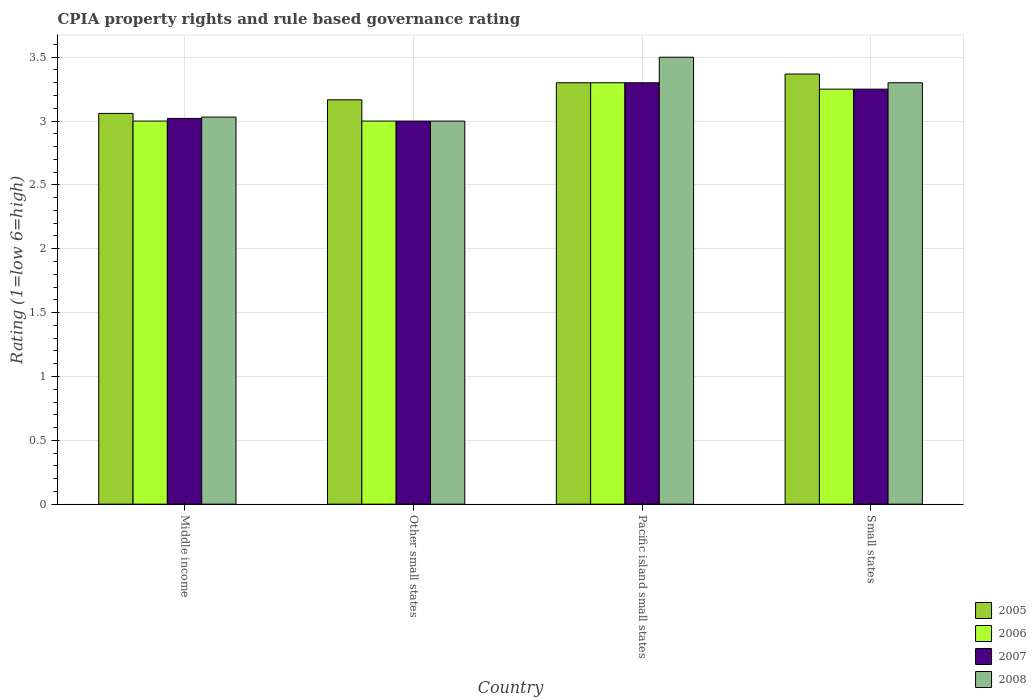How many groups of bars are there?
Make the answer very short. 4. Are the number of bars on each tick of the X-axis equal?
Your answer should be very brief. Yes. How many bars are there on the 4th tick from the right?
Your answer should be compact. 4. What is the label of the 1st group of bars from the left?
Your response must be concise. Middle income. In how many cases, is the number of bars for a given country not equal to the number of legend labels?
Your answer should be very brief. 0. Across all countries, what is the maximum CPIA rating in 2005?
Make the answer very short. 3.37. In which country was the CPIA rating in 2005 maximum?
Ensure brevity in your answer.  Small states. In which country was the CPIA rating in 2007 minimum?
Make the answer very short. Other small states. What is the total CPIA rating in 2008 in the graph?
Provide a short and direct response. 12.83. What is the difference between the CPIA rating in 2007 in Middle income and that in Small states?
Provide a short and direct response. -0.23. What is the difference between the CPIA rating in 2008 in Small states and the CPIA rating in 2006 in Pacific island small states?
Ensure brevity in your answer.  0. What is the average CPIA rating in 2007 per country?
Make the answer very short. 3.14. What is the difference between the CPIA rating of/in 2005 and CPIA rating of/in 2007 in Small states?
Offer a terse response. 0.12. In how many countries, is the CPIA rating in 2007 greater than 1.6?
Offer a terse response. 4. What is the ratio of the CPIA rating in 2006 in Other small states to that in Pacific island small states?
Provide a short and direct response. 0.91. What is the difference between the highest and the second highest CPIA rating in 2008?
Give a very brief answer. 0.27. What is the difference between the highest and the lowest CPIA rating in 2006?
Provide a short and direct response. 0.3. Is the sum of the CPIA rating in 2007 in Middle income and Other small states greater than the maximum CPIA rating in 2005 across all countries?
Ensure brevity in your answer.  Yes. Is it the case that in every country, the sum of the CPIA rating in 2008 and CPIA rating in 2007 is greater than the sum of CPIA rating in 2005 and CPIA rating in 2006?
Give a very brief answer. No. What does the 2nd bar from the left in Pacific island small states represents?
Your response must be concise. 2006. Where does the legend appear in the graph?
Your answer should be very brief. Bottom right. How many legend labels are there?
Keep it short and to the point. 4. How are the legend labels stacked?
Offer a very short reply. Vertical. What is the title of the graph?
Provide a short and direct response. CPIA property rights and rule based governance rating. What is the label or title of the X-axis?
Keep it short and to the point. Country. What is the Rating (1=low 6=high) of 2005 in Middle income?
Provide a short and direct response. 3.06. What is the Rating (1=low 6=high) of 2007 in Middle income?
Provide a short and direct response. 3.02. What is the Rating (1=low 6=high) of 2008 in Middle income?
Provide a succinct answer. 3.03. What is the Rating (1=low 6=high) of 2005 in Other small states?
Provide a succinct answer. 3.17. What is the Rating (1=low 6=high) of 2006 in Other small states?
Provide a succinct answer. 3. What is the Rating (1=low 6=high) of 2007 in Other small states?
Offer a very short reply. 3. What is the Rating (1=low 6=high) in 2005 in Pacific island small states?
Your response must be concise. 3.3. What is the Rating (1=low 6=high) of 2006 in Pacific island small states?
Offer a very short reply. 3.3. What is the Rating (1=low 6=high) in 2007 in Pacific island small states?
Provide a short and direct response. 3.3. What is the Rating (1=low 6=high) of 2005 in Small states?
Keep it short and to the point. 3.37. What is the Rating (1=low 6=high) in 2008 in Small states?
Make the answer very short. 3.3. Across all countries, what is the maximum Rating (1=low 6=high) of 2005?
Ensure brevity in your answer.  3.37. Across all countries, what is the maximum Rating (1=low 6=high) in 2006?
Offer a very short reply. 3.3. Across all countries, what is the maximum Rating (1=low 6=high) of 2007?
Offer a very short reply. 3.3. Across all countries, what is the maximum Rating (1=low 6=high) in 2008?
Offer a terse response. 3.5. Across all countries, what is the minimum Rating (1=low 6=high) in 2005?
Keep it short and to the point. 3.06. Across all countries, what is the minimum Rating (1=low 6=high) of 2006?
Provide a short and direct response. 3. Across all countries, what is the minimum Rating (1=low 6=high) in 2007?
Make the answer very short. 3. Across all countries, what is the minimum Rating (1=low 6=high) in 2008?
Your answer should be very brief. 3. What is the total Rating (1=low 6=high) in 2005 in the graph?
Keep it short and to the point. 12.9. What is the total Rating (1=low 6=high) of 2006 in the graph?
Your response must be concise. 12.55. What is the total Rating (1=low 6=high) of 2007 in the graph?
Make the answer very short. 12.57. What is the total Rating (1=low 6=high) of 2008 in the graph?
Provide a succinct answer. 12.83. What is the difference between the Rating (1=low 6=high) in 2005 in Middle income and that in Other small states?
Your response must be concise. -0.11. What is the difference between the Rating (1=low 6=high) of 2007 in Middle income and that in Other small states?
Your answer should be very brief. 0.02. What is the difference between the Rating (1=low 6=high) of 2008 in Middle income and that in Other small states?
Provide a short and direct response. 0.03. What is the difference between the Rating (1=low 6=high) of 2005 in Middle income and that in Pacific island small states?
Your response must be concise. -0.24. What is the difference between the Rating (1=low 6=high) of 2006 in Middle income and that in Pacific island small states?
Your answer should be compact. -0.3. What is the difference between the Rating (1=low 6=high) in 2007 in Middle income and that in Pacific island small states?
Offer a terse response. -0.28. What is the difference between the Rating (1=low 6=high) of 2008 in Middle income and that in Pacific island small states?
Your answer should be very brief. -0.47. What is the difference between the Rating (1=low 6=high) in 2005 in Middle income and that in Small states?
Provide a short and direct response. -0.31. What is the difference between the Rating (1=low 6=high) in 2007 in Middle income and that in Small states?
Offer a terse response. -0.23. What is the difference between the Rating (1=low 6=high) in 2008 in Middle income and that in Small states?
Your response must be concise. -0.27. What is the difference between the Rating (1=low 6=high) in 2005 in Other small states and that in Pacific island small states?
Your answer should be compact. -0.13. What is the difference between the Rating (1=low 6=high) of 2007 in Other small states and that in Pacific island small states?
Offer a terse response. -0.3. What is the difference between the Rating (1=low 6=high) of 2005 in Other small states and that in Small states?
Your response must be concise. -0.2. What is the difference between the Rating (1=low 6=high) in 2006 in Other small states and that in Small states?
Your answer should be compact. -0.25. What is the difference between the Rating (1=low 6=high) in 2007 in Other small states and that in Small states?
Ensure brevity in your answer.  -0.25. What is the difference between the Rating (1=low 6=high) of 2008 in Other small states and that in Small states?
Provide a short and direct response. -0.3. What is the difference between the Rating (1=low 6=high) in 2005 in Pacific island small states and that in Small states?
Make the answer very short. -0.07. What is the difference between the Rating (1=low 6=high) in 2007 in Pacific island small states and that in Small states?
Keep it short and to the point. 0.05. What is the difference between the Rating (1=low 6=high) of 2007 in Middle income and the Rating (1=low 6=high) of 2008 in Other small states?
Offer a terse response. 0.02. What is the difference between the Rating (1=low 6=high) of 2005 in Middle income and the Rating (1=low 6=high) of 2006 in Pacific island small states?
Your answer should be compact. -0.24. What is the difference between the Rating (1=low 6=high) in 2005 in Middle income and the Rating (1=low 6=high) in 2007 in Pacific island small states?
Your answer should be compact. -0.24. What is the difference between the Rating (1=low 6=high) of 2005 in Middle income and the Rating (1=low 6=high) of 2008 in Pacific island small states?
Provide a succinct answer. -0.44. What is the difference between the Rating (1=low 6=high) of 2006 in Middle income and the Rating (1=low 6=high) of 2007 in Pacific island small states?
Provide a succinct answer. -0.3. What is the difference between the Rating (1=low 6=high) of 2006 in Middle income and the Rating (1=low 6=high) of 2008 in Pacific island small states?
Ensure brevity in your answer.  -0.5. What is the difference between the Rating (1=low 6=high) in 2007 in Middle income and the Rating (1=low 6=high) in 2008 in Pacific island small states?
Provide a succinct answer. -0.48. What is the difference between the Rating (1=low 6=high) in 2005 in Middle income and the Rating (1=low 6=high) in 2006 in Small states?
Keep it short and to the point. -0.19. What is the difference between the Rating (1=low 6=high) of 2005 in Middle income and the Rating (1=low 6=high) of 2007 in Small states?
Offer a terse response. -0.19. What is the difference between the Rating (1=low 6=high) in 2005 in Middle income and the Rating (1=low 6=high) in 2008 in Small states?
Your response must be concise. -0.24. What is the difference between the Rating (1=low 6=high) of 2007 in Middle income and the Rating (1=low 6=high) of 2008 in Small states?
Your answer should be compact. -0.28. What is the difference between the Rating (1=low 6=high) in 2005 in Other small states and the Rating (1=low 6=high) in 2006 in Pacific island small states?
Your answer should be very brief. -0.13. What is the difference between the Rating (1=low 6=high) of 2005 in Other small states and the Rating (1=low 6=high) of 2007 in Pacific island small states?
Ensure brevity in your answer.  -0.13. What is the difference between the Rating (1=low 6=high) of 2006 in Other small states and the Rating (1=low 6=high) of 2007 in Pacific island small states?
Offer a terse response. -0.3. What is the difference between the Rating (1=low 6=high) in 2007 in Other small states and the Rating (1=low 6=high) in 2008 in Pacific island small states?
Your answer should be compact. -0.5. What is the difference between the Rating (1=low 6=high) in 2005 in Other small states and the Rating (1=low 6=high) in 2006 in Small states?
Provide a short and direct response. -0.08. What is the difference between the Rating (1=low 6=high) in 2005 in Other small states and the Rating (1=low 6=high) in 2007 in Small states?
Offer a very short reply. -0.08. What is the difference between the Rating (1=low 6=high) in 2005 in Other small states and the Rating (1=low 6=high) in 2008 in Small states?
Your answer should be very brief. -0.13. What is the difference between the Rating (1=low 6=high) of 2007 in Other small states and the Rating (1=low 6=high) of 2008 in Small states?
Provide a short and direct response. -0.3. What is the difference between the Rating (1=low 6=high) of 2005 in Pacific island small states and the Rating (1=low 6=high) of 2008 in Small states?
Make the answer very short. 0. What is the difference between the Rating (1=low 6=high) of 2006 in Pacific island small states and the Rating (1=low 6=high) of 2008 in Small states?
Offer a very short reply. 0. What is the average Rating (1=low 6=high) of 2005 per country?
Your response must be concise. 3.22. What is the average Rating (1=low 6=high) in 2006 per country?
Offer a very short reply. 3.14. What is the average Rating (1=low 6=high) of 2007 per country?
Offer a very short reply. 3.14. What is the average Rating (1=low 6=high) of 2008 per country?
Offer a terse response. 3.21. What is the difference between the Rating (1=low 6=high) in 2005 and Rating (1=low 6=high) in 2007 in Middle income?
Keep it short and to the point. 0.04. What is the difference between the Rating (1=low 6=high) in 2005 and Rating (1=low 6=high) in 2008 in Middle income?
Your answer should be very brief. 0.03. What is the difference between the Rating (1=low 6=high) in 2006 and Rating (1=low 6=high) in 2007 in Middle income?
Make the answer very short. -0.02. What is the difference between the Rating (1=low 6=high) in 2006 and Rating (1=low 6=high) in 2008 in Middle income?
Offer a terse response. -0.03. What is the difference between the Rating (1=low 6=high) in 2007 and Rating (1=low 6=high) in 2008 in Middle income?
Ensure brevity in your answer.  -0.01. What is the difference between the Rating (1=low 6=high) in 2005 and Rating (1=low 6=high) in 2006 in Other small states?
Keep it short and to the point. 0.17. What is the difference between the Rating (1=low 6=high) of 2005 and Rating (1=low 6=high) of 2007 in Other small states?
Provide a succinct answer. 0.17. What is the difference between the Rating (1=low 6=high) of 2005 and Rating (1=low 6=high) of 2008 in Other small states?
Offer a very short reply. 0.17. What is the difference between the Rating (1=low 6=high) in 2006 and Rating (1=low 6=high) in 2007 in Other small states?
Provide a short and direct response. 0. What is the difference between the Rating (1=low 6=high) in 2006 and Rating (1=low 6=high) in 2008 in Other small states?
Provide a succinct answer. 0. What is the difference between the Rating (1=low 6=high) in 2007 and Rating (1=low 6=high) in 2008 in Pacific island small states?
Give a very brief answer. -0.2. What is the difference between the Rating (1=low 6=high) in 2005 and Rating (1=low 6=high) in 2006 in Small states?
Provide a short and direct response. 0.12. What is the difference between the Rating (1=low 6=high) of 2005 and Rating (1=low 6=high) of 2007 in Small states?
Your answer should be very brief. 0.12. What is the difference between the Rating (1=low 6=high) of 2005 and Rating (1=low 6=high) of 2008 in Small states?
Offer a very short reply. 0.07. What is the difference between the Rating (1=low 6=high) of 2006 and Rating (1=low 6=high) of 2008 in Small states?
Keep it short and to the point. -0.05. What is the difference between the Rating (1=low 6=high) of 2007 and Rating (1=low 6=high) of 2008 in Small states?
Provide a succinct answer. -0.05. What is the ratio of the Rating (1=low 6=high) in 2005 in Middle income to that in Other small states?
Offer a terse response. 0.97. What is the ratio of the Rating (1=low 6=high) of 2006 in Middle income to that in Other small states?
Offer a very short reply. 1. What is the ratio of the Rating (1=low 6=high) in 2007 in Middle income to that in Other small states?
Your answer should be very brief. 1.01. What is the ratio of the Rating (1=low 6=high) of 2008 in Middle income to that in Other small states?
Give a very brief answer. 1.01. What is the ratio of the Rating (1=low 6=high) of 2005 in Middle income to that in Pacific island small states?
Your answer should be very brief. 0.93. What is the ratio of the Rating (1=low 6=high) of 2006 in Middle income to that in Pacific island small states?
Offer a very short reply. 0.91. What is the ratio of the Rating (1=low 6=high) in 2007 in Middle income to that in Pacific island small states?
Your response must be concise. 0.92. What is the ratio of the Rating (1=low 6=high) of 2008 in Middle income to that in Pacific island small states?
Your response must be concise. 0.87. What is the ratio of the Rating (1=low 6=high) in 2005 in Middle income to that in Small states?
Keep it short and to the point. 0.91. What is the ratio of the Rating (1=low 6=high) of 2006 in Middle income to that in Small states?
Your answer should be very brief. 0.92. What is the ratio of the Rating (1=low 6=high) in 2007 in Middle income to that in Small states?
Make the answer very short. 0.93. What is the ratio of the Rating (1=low 6=high) in 2008 in Middle income to that in Small states?
Your answer should be very brief. 0.92. What is the ratio of the Rating (1=low 6=high) of 2005 in Other small states to that in Pacific island small states?
Your response must be concise. 0.96. What is the ratio of the Rating (1=low 6=high) of 2006 in Other small states to that in Pacific island small states?
Your response must be concise. 0.91. What is the ratio of the Rating (1=low 6=high) of 2007 in Other small states to that in Pacific island small states?
Ensure brevity in your answer.  0.91. What is the ratio of the Rating (1=low 6=high) in 2008 in Other small states to that in Pacific island small states?
Your answer should be compact. 0.86. What is the ratio of the Rating (1=low 6=high) in 2005 in Other small states to that in Small states?
Your response must be concise. 0.94. What is the ratio of the Rating (1=low 6=high) in 2006 in Other small states to that in Small states?
Your answer should be very brief. 0.92. What is the ratio of the Rating (1=low 6=high) of 2007 in Other small states to that in Small states?
Your answer should be compact. 0.92. What is the ratio of the Rating (1=low 6=high) in 2008 in Other small states to that in Small states?
Provide a short and direct response. 0.91. What is the ratio of the Rating (1=low 6=high) of 2005 in Pacific island small states to that in Small states?
Provide a succinct answer. 0.98. What is the ratio of the Rating (1=low 6=high) in 2006 in Pacific island small states to that in Small states?
Your answer should be very brief. 1.02. What is the ratio of the Rating (1=low 6=high) of 2007 in Pacific island small states to that in Small states?
Offer a very short reply. 1.02. What is the ratio of the Rating (1=low 6=high) in 2008 in Pacific island small states to that in Small states?
Give a very brief answer. 1.06. What is the difference between the highest and the second highest Rating (1=low 6=high) in 2005?
Keep it short and to the point. 0.07. What is the difference between the highest and the second highest Rating (1=low 6=high) of 2006?
Your response must be concise. 0.05. What is the difference between the highest and the second highest Rating (1=low 6=high) of 2007?
Your answer should be compact. 0.05. What is the difference between the highest and the second highest Rating (1=low 6=high) in 2008?
Make the answer very short. 0.2. What is the difference between the highest and the lowest Rating (1=low 6=high) of 2005?
Keep it short and to the point. 0.31. What is the difference between the highest and the lowest Rating (1=low 6=high) of 2006?
Your response must be concise. 0.3. What is the difference between the highest and the lowest Rating (1=low 6=high) in 2007?
Provide a short and direct response. 0.3. What is the difference between the highest and the lowest Rating (1=low 6=high) in 2008?
Your answer should be compact. 0.5. 